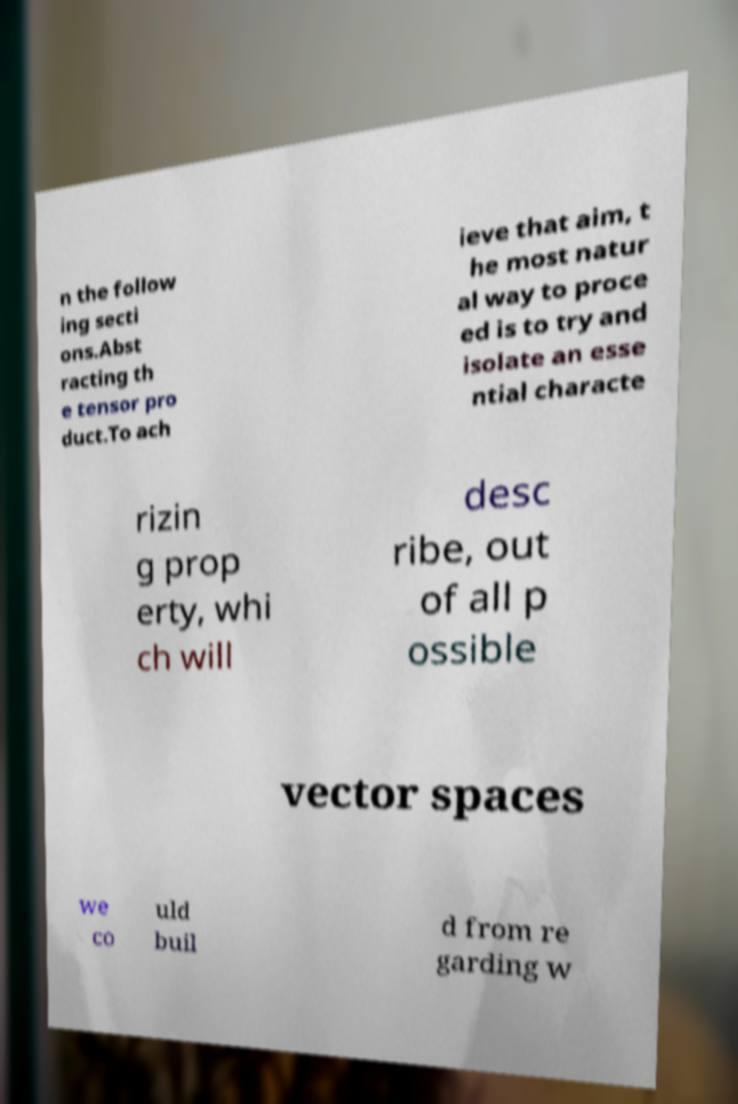For documentation purposes, I need the text within this image transcribed. Could you provide that? n the follow ing secti ons.Abst racting th e tensor pro duct.To ach ieve that aim, t he most natur al way to proce ed is to try and isolate an esse ntial characte rizin g prop erty, whi ch will desc ribe, out of all p ossible vector spaces we co uld buil d from re garding w 